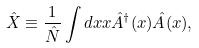<formula> <loc_0><loc_0><loc_500><loc_500>\hat { X } & \equiv \frac { 1 } { \hat { N } } \int d x x \hat { A } ^ { \dagger } ( x ) \hat { A } ( x ) ,</formula> 